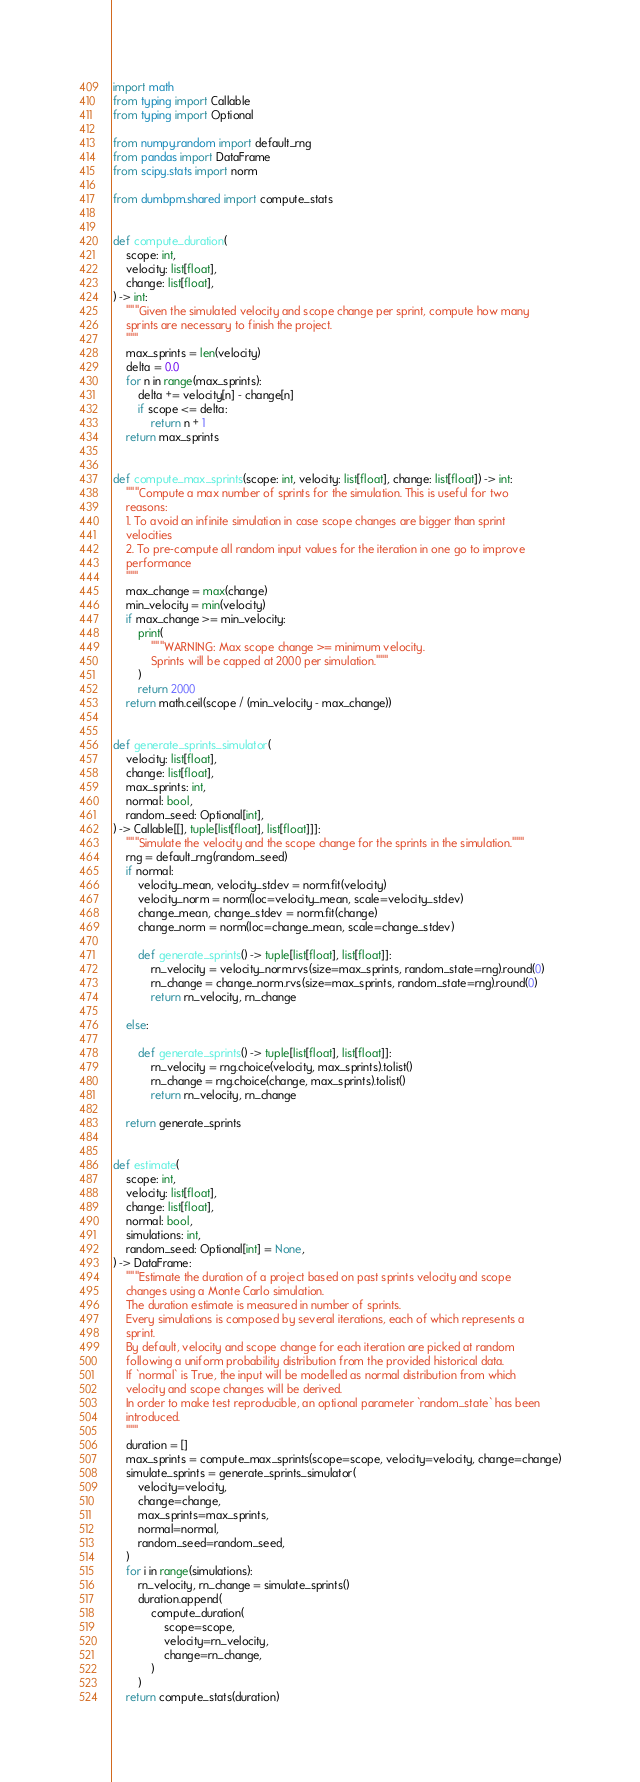Convert code to text. <code><loc_0><loc_0><loc_500><loc_500><_Python_>import math
from typing import Callable
from typing import Optional

from numpy.random import default_rng
from pandas import DataFrame
from scipy.stats import norm

from dumbpm.shared import compute_stats


def compute_duration(
    scope: int,
    velocity: list[float],
    change: list[float],
) -> int:
    """Given the simulated velocity and scope change per sprint, compute how many
    sprints are necessary to finish the project.
    """
    max_sprints = len(velocity)
    delta = 0.0
    for n in range(max_sprints):
        delta += velocity[n] - change[n]
        if scope <= delta:
            return n + 1
    return max_sprints


def compute_max_sprints(scope: int, velocity: list[float], change: list[float]) -> int:
    """Compute a max number of sprints for the simulation. This is useful for two
    reasons:
    1. To avoid an infinite simulation in case scope changes are bigger than sprint
    velocities
    2. To pre-compute all random input values for the iteration in one go to improve
    performance
    """
    max_change = max(change)
    min_velocity = min(velocity)
    if max_change >= min_velocity:
        print(
            """WARNING: Max scope change >= minimum velocity.
            Sprints will be capped at 2000 per simulation."""
        )
        return 2000
    return math.ceil(scope / (min_velocity - max_change))


def generate_sprints_simulator(
    velocity: list[float],
    change: list[float],
    max_sprints: int,
    normal: bool,
    random_seed: Optional[int],
) -> Callable[[], tuple[list[float], list[float]]]:
    """Simulate the velocity and the scope change for the sprints in the simulation."""
    rng = default_rng(random_seed)
    if normal:
        velocity_mean, velocity_stdev = norm.fit(velocity)
        velocity_norm = norm(loc=velocity_mean, scale=velocity_stdev)
        change_mean, change_stdev = norm.fit(change)
        change_norm = norm(loc=change_mean, scale=change_stdev)

        def generate_sprints() -> tuple[list[float], list[float]]:
            rn_velocity = velocity_norm.rvs(size=max_sprints, random_state=rng).round(0)
            rn_change = change_norm.rvs(size=max_sprints, random_state=rng).round(0)
            return rn_velocity, rn_change

    else:

        def generate_sprints() -> tuple[list[float], list[float]]:
            rn_velocity = rng.choice(velocity, max_sprints).tolist()
            rn_change = rng.choice(change, max_sprints).tolist()
            return rn_velocity, rn_change

    return generate_sprints


def estimate(
    scope: int,
    velocity: list[float],
    change: list[float],
    normal: bool,
    simulations: int,
    random_seed: Optional[int] = None,
) -> DataFrame:
    """Estimate the duration of a project based on past sprints velocity and scope
    changes using a Monte Carlo simulation.
    The duration estimate is measured in number of sprints.
    Every simulations is composed by several iterations, each of which represents a
    sprint.
    By default, velocity and scope change for each iteration are picked at random
    following a uniform probability distribution from the provided historical data.
    If `normal` is True, the input will be modelled as normal distribution from which
    velocity and scope changes will be derived.
    In order to make test reproducible, an optional parameter `random_state` has been
    introduced.
    """
    duration = []
    max_sprints = compute_max_sprints(scope=scope, velocity=velocity, change=change)
    simulate_sprints = generate_sprints_simulator(
        velocity=velocity,
        change=change,
        max_sprints=max_sprints,
        normal=normal,
        random_seed=random_seed,
    )
    for i in range(simulations):
        rn_velocity, rn_change = simulate_sprints()
        duration.append(
            compute_duration(
                scope=scope,
                velocity=rn_velocity,
                change=rn_change,
            )
        )
    return compute_stats(duration)
</code> 